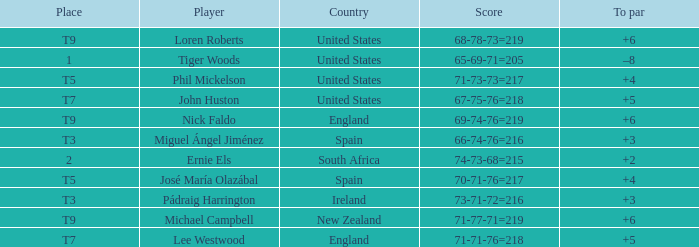Would you be able to parse every entry in this table? {'header': ['Place', 'Player', 'Country', 'Score', 'To par'], 'rows': [['T9', 'Loren Roberts', 'United States', '68-78-73=219', '+6'], ['1', 'Tiger Woods', 'United States', '65-69-71=205', '–8'], ['T5', 'Phil Mickelson', 'United States', '71-73-73=217', '+4'], ['T7', 'John Huston', 'United States', '67-75-76=218', '+5'], ['T9', 'Nick Faldo', 'England', '69-74-76=219', '+6'], ['T3', 'Miguel Ángel Jiménez', 'Spain', '66-74-76=216', '+3'], ['2', 'Ernie Els', 'South Africa', '74-73-68=215', '+2'], ['T5', 'José María Olazábal', 'Spain', '70-71-76=217', '+4'], ['T3', 'Pádraig Harrington', 'Ireland', '73-71-72=216', '+3'], ['T9', 'Michael Campbell', 'New Zealand', '71-77-71=219', '+6'], ['T7', 'Lee Westwood', 'England', '71-71-76=218', '+5']]} What is To Par, when Place is "T5", and when Country is "United States"? 4.0. 